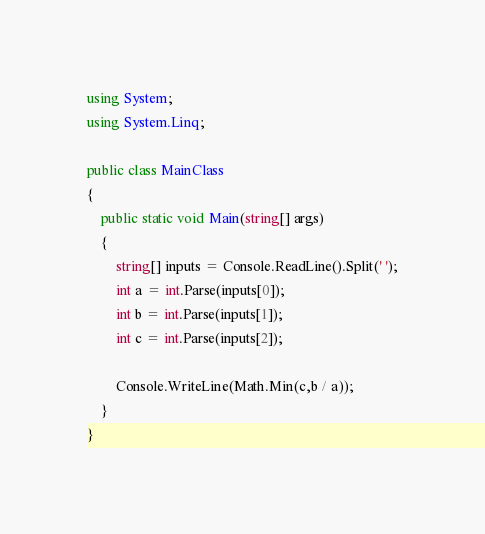<code> <loc_0><loc_0><loc_500><loc_500><_C#_>using System;
using System.Linq;

public class MainClass
{
	public static void Main(string[] args)
	{
		string[] inputs = Console.ReadLine().Split(' ');
		int a = int.Parse(inputs[0]);
		int b = int.Parse(inputs[1]);
		int c = int.Parse(inputs[2]);
		
		Console.WriteLine(Math.Min(c,b / a));
	}
}</code> 